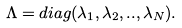<formula> <loc_0><loc_0><loc_500><loc_500>\Lambda = d i a g ( \lambda _ { 1 } , \lambda _ { 2 } , . . , \lambda _ { N } ) .</formula> 